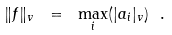<formula> <loc_0><loc_0><loc_500><loc_500>\| f \| _ { v } \ = \ \max _ { i } ( | a _ { i } | _ { v } ) \ .</formula> 